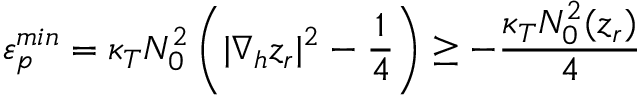<formula> <loc_0><loc_0><loc_500><loc_500>\varepsilon _ { p } ^ { \min } = \kappa _ { T } N _ { 0 } ^ { 2 } \left ( | \nabla _ { h } z _ { r } | ^ { 2 } - \frac { 1 } { 4 } \right ) \geq - \frac { \kappa _ { T } N _ { 0 } ^ { 2 } ( z _ { r } ) } { 4 }</formula> 